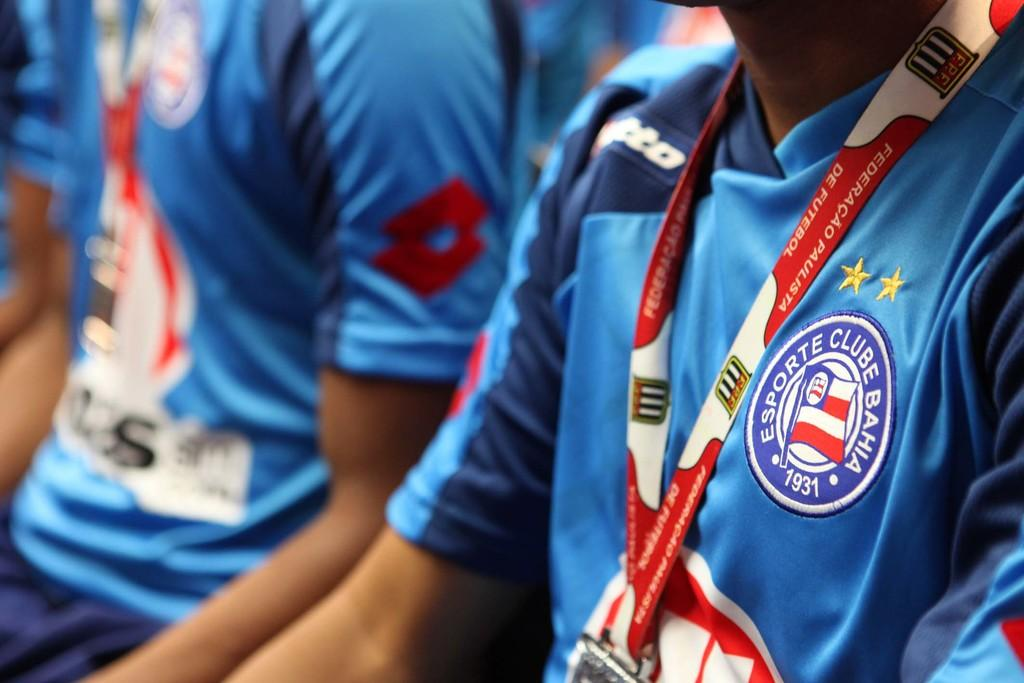<image>
Write a terse but informative summary of the picture. the word esporte that is on a jersey 